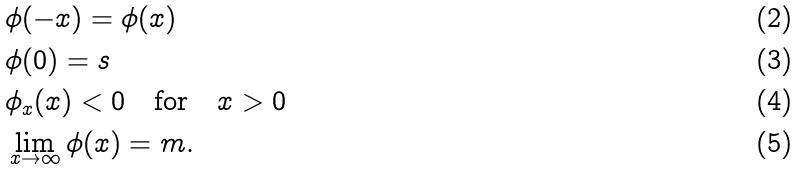Convert formula to latex. <formula><loc_0><loc_0><loc_500><loc_500>& \phi ( - x ) = \phi ( x ) \\ & \phi ( 0 ) = s \\ & \phi _ { x } ( x ) < 0 \quad \text {for} \quad x > 0 \\ & \lim _ { x \to \infty } \phi ( x ) = m .</formula> 